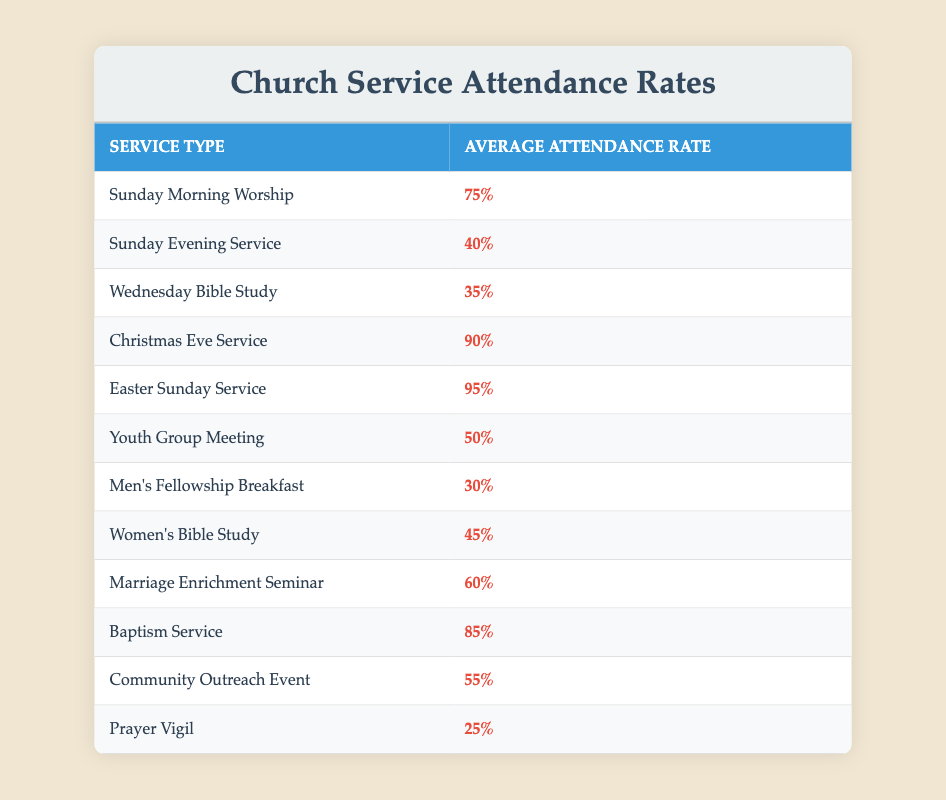What is the attendance rate for the Christmas Eve Service? The table lists the average attendance rates for different church services. For the Christmas Eve Service, the average attendance rate is explicitly stated as 90%.
Answer: 90% Which service has the highest attendance rate? By reviewing the table, the attendance rates for each service are compared. The Easter Sunday Service has the highest attendance rate, which is stated as 95%.
Answer: 95% What is the average attendance rate of the Sunday Evening Service and the Wednesday Bible Study? The attendance rates for these two services are 40% and 35%, respectively. To find the average, we sum these two rates: 40% + 35% = 75%. Then we divide by 2 (the number of services): 75% / 2 = 37.5%.
Answer: 37.5% Is the attendance rate for the Men's Fellowship Breakfast higher than 30%? The attendance rate for the Men's Fellowship Breakfast is listed as 30%. Since it is not higher than this value, the answer is no.
Answer: No How many services have an attendance rate below 50%? By checking the table, we see the services with attendance rates below 50% are: Sunday Evening Service (40%), Wednesday Bible Study (35%), Men's Fellowship Breakfast (30%), Women's Bible Study (45%), Youth Group Meeting (50%), and Prayer Vigil (25%). There are 4 services (Sunday Evening, Wednesday, Men's Fellowship, and Prayer Vigil) that have attendance rates below 50%.
Answer: 4 What is the difference in attendance rates between the Christmas Eve Service and the Prayer Vigil? The attendance rate for the Christmas Eve Service is 90%, while the Prayer Vigil's rate is 25%. To find the difference, we subtract the lower number from the higher one: 90% - 25% = 65%.
Answer: 65% 